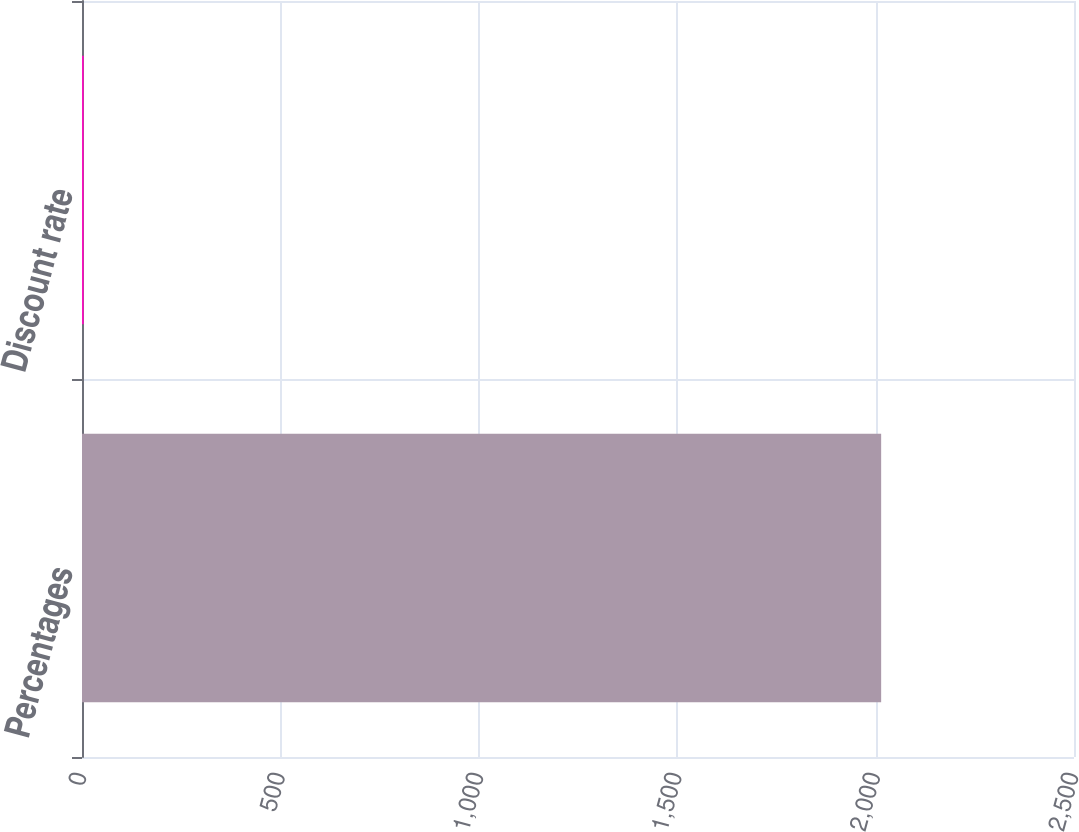<chart> <loc_0><loc_0><loc_500><loc_500><bar_chart><fcel>Percentages<fcel>Discount rate<nl><fcel>2014<fcel>4.35<nl></chart> 